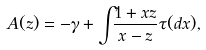Convert formula to latex. <formula><loc_0><loc_0><loc_500><loc_500>A ( z ) = - \gamma + \int _ { \real } \frac { 1 + x z } { x - z } \tau ( d x ) ,</formula> 